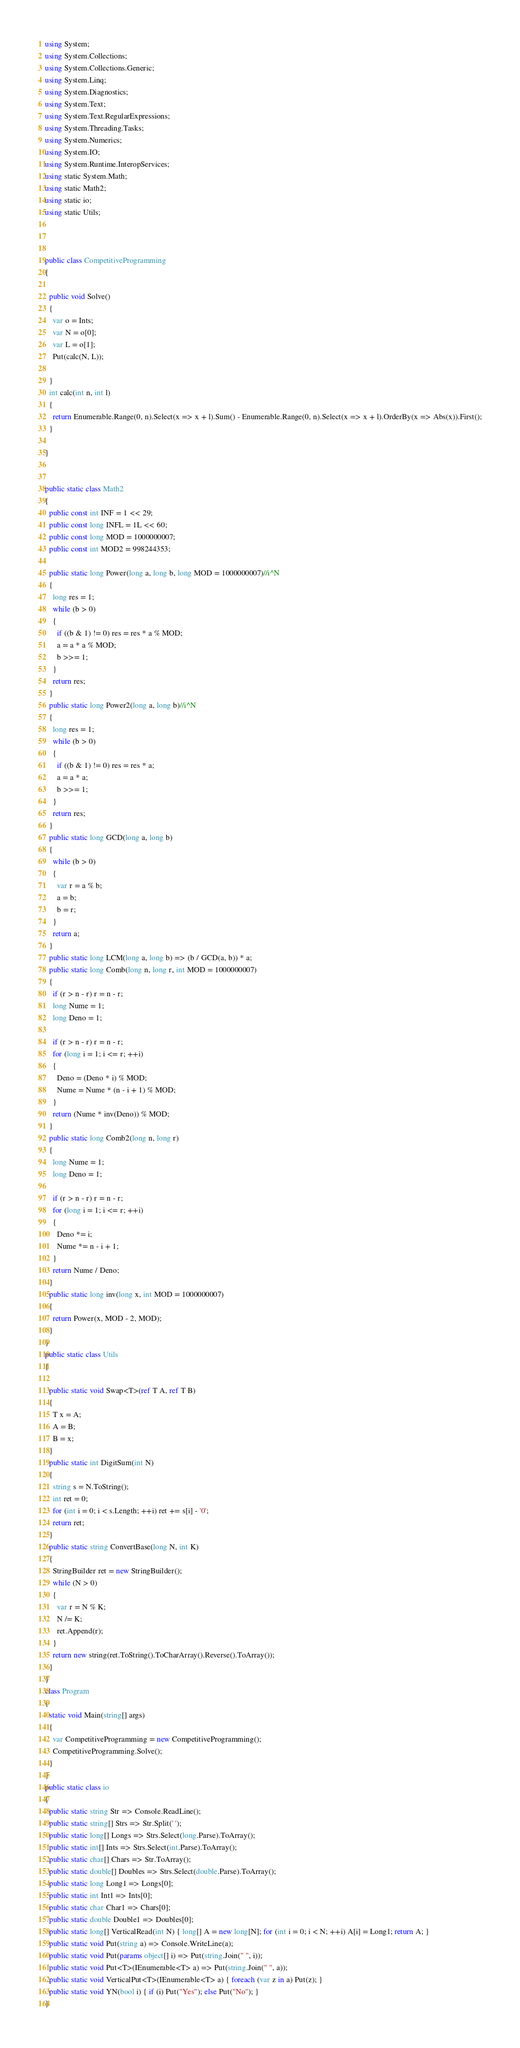<code> <loc_0><loc_0><loc_500><loc_500><_C#_>using System;
using System.Collections;
using System.Collections.Generic;
using System.Linq;
using System.Diagnostics;
using System.Text;
using System.Text.RegularExpressions;
using System.Threading.Tasks;
using System.Numerics;
using System.IO;
using System.Runtime.InteropServices;
using static System.Math;
using static Math2;
using static io;
using static Utils;



public class CompetitiveProgramming
{

  public void Solve()
  {
    var o = Ints;
    var N = o[0];
    var L = o[1];
    Put(calc(N, L));

  }
  int calc(int n, int l)
  {
    return Enumerable.Range(0, n).Select(x => x + l).Sum() - Enumerable.Range(0, n).Select(x => x + l).OrderBy(x => Abs(x)).First();
  }

}


public static class Math2
{
  public const int INF = 1 << 29;
  public const long INFL = 1L << 60;
  public const long MOD = 1000000007;
  public const int MOD2 = 998244353;

  public static long Power(long a, long b, long MOD = 1000000007)//i^N
  {
    long res = 1;
    while (b > 0)
    {
      if ((b & 1) != 0) res = res * a % MOD;
      a = a * a % MOD;
      b >>= 1;
    }
    return res;
  }
  public static long Power2(long a, long b)//i^N
  {
    long res = 1;
    while (b > 0)
    {
      if ((b & 1) != 0) res = res * a;
      a = a * a;
      b >>= 1;
    }
    return res;
  }
  public static long GCD(long a, long b)
  {
    while (b > 0)
    {
      var r = a % b;
      a = b;
      b = r;
    }
    return a;
  }
  public static long LCM(long a, long b) => (b / GCD(a, b)) * a;
  public static long Comb(long n, long r, int MOD = 1000000007)
  {
    if (r > n - r) r = n - r;
    long Nume = 1;
    long Deno = 1;

    if (r > n - r) r = n - r;
    for (long i = 1; i <= r; ++i)
    {
      Deno = (Deno * i) % MOD;
      Nume = Nume * (n - i + 1) % MOD;
    }
    return (Nume * inv(Deno)) % MOD;
  }
  public static long Comb2(long n, long r)
  {
    long Nume = 1;
    long Deno = 1;

    if (r > n - r) r = n - r;
    for (long i = 1; i <= r; ++i)
    {
      Deno *= i;
      Nume *= n - i + 1;
    }
    return Nume / Deno;
  }
  public static long inv(long x, int MOD = 1000000007)
  {
    return Power(x, MOD - 2, MOD);
  }
}
public static class Utils
{

  public static void Swap<T>(ref T A, ref T B)
  {
    T x = A;
    A = B;
    B = x;
  }
  public static int DigitSum(int N)
  {
    string s = N.ToString();
    int ret = 0;
    for (int i = 0; i < s.Length; ++i) ret += s[i] - '0';
    return ret;
  }
  public static string ConvertBase(long N, int K)
  {
    StringBuilder ret = new StringBuilder();
    while (N > 0)
    {
      var r = N % K;
      N /= K;
      ret.Append(r);
    }
    return new string(ret.ToString().ToCharArray().Reverse().ToArray());
  }
}
class Program
{
  static void Main(string[] args)
  {
    var CompetitiveProgramming = new CompetitiveProgramming();
    CompetitiveProgramming.Solve();
  }
}
public static class io
{
  public static string Str => Console.ReadLine();
  public static string[] Strs => Str.Split(' ');
  public static long[] Longs => Strs.Select(long.Parse).ToArray();
  public static int[] Ints => Strs.Select(int.Parse).ToArray();
  public static char[] Chars => Str.ToArray();
  public static double[] Doubles => Strs.Select(double.Parse).ToArray();
  public static long Long1 => Longs[0];
  public static int Int1 => Ints[0];
  public static char Char1 => Chars[0];
  public static double Double1 => Doubles[0];
  public static long[] VerticalRead(int N) { long[] A = new long[N]; for (int i = 0; i < N; ++i) A[i] = Long1; return A; }
  public static void Put(string a) => Console.WriteLine(a);
  public static void Put(params object[] i) => Put(string.Join(" ", i));
  public static void Put<T>(IEnumerable<T> a) => Put(string.Join(" ", a));
  public static void VerticalPut<T>(IEnumerable<T> a) { foreach (var z in a) Put(z); }
  public static void YN(bool i) { if (i) Put("Yes"); else Put("No"); }
}</code> 